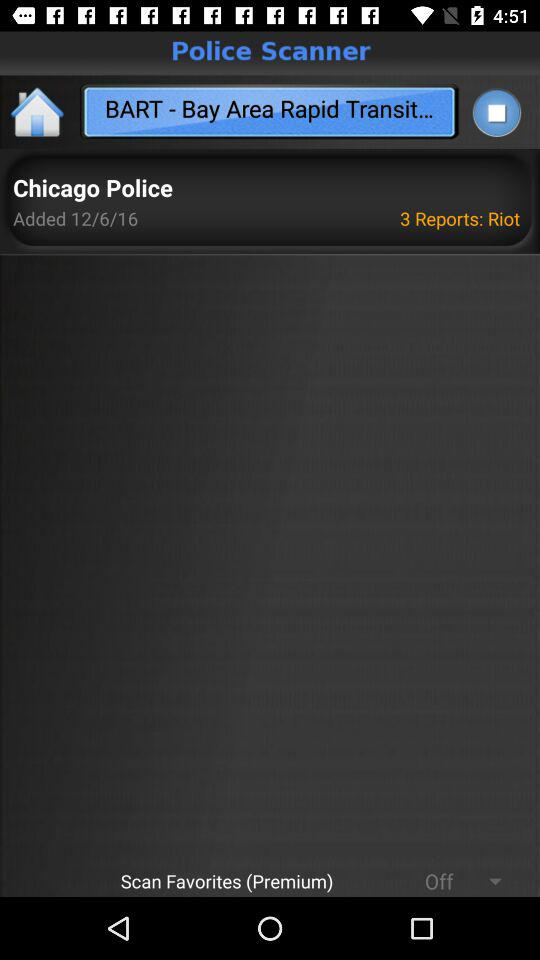What is the full form of BART? The full form of BART is "Bay Area Rapid Transit...". 